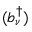<formula> <loc_0><loc_0><loc_500><loc_500>( b _ { \nu } ^ { \dagger } )</formula> 